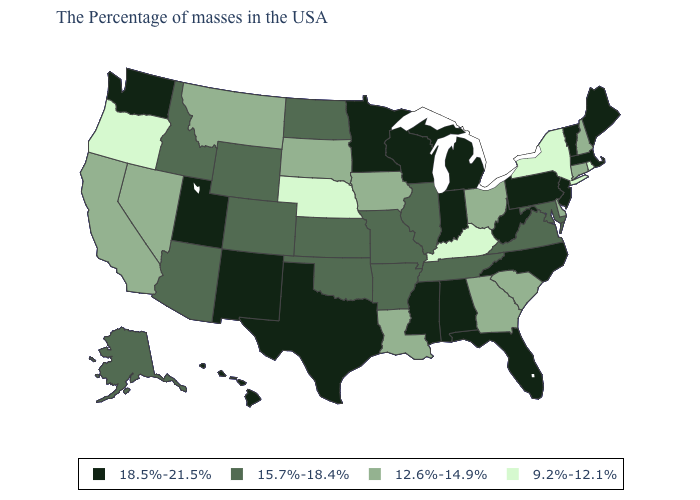Name the states that have a value in the range 18.5%-21.5%?
Answer briefly. Maine, Massachusetts, Vermont, New Jersey, Pennsylvania, North Carolina, West Virginia, Florida, Michigan, Indiana, Alabama, Wisconsin, Mississippi, Minnesota, Texas, New Mexico, Utah, Washington, Hawaii. Is the legend a continuous bar?
Give a very brief answer. No. What is the value of New Mexico?
Answer briefly. 18.5%-21.5%. Does South Dakota have the highest value in the USA?
Be succinct. No. Which states have the highest value in the USA?
Concise answer only. Maine, Massachusetts, Vermont, New Jersey, Pennsylvania, North Carolina, West Virginia, Florida, Michigan, Indiana, Alabama, Wisconsin, Mississippi, Minnesota, Texas, New Mexico, Utah, Washington, Hawaii. Does the first symbol in the legend represent the smallest category?
Answer briefly. No. How many symbols are there in the legend?
Write a very short answer. 4. What is the value of Maine?
Concise answer only. 18.5%-21.5%. Name the states that have a value in the range 12.6%-14.9%?
Concise answer only. New Hampshire, Connecticut, Delaware, South Carolina, Ohio, Georgia, Louisiana, Iowa, South Dakota, Montana, Nevada, California. Does Kentucky have the lowest value in the USA?
Keep it brief. Yes. Which states hav the highest value in the South?
Answer briefly. North Carolina, West Virginia, Florida, Alabama, Mississippi, Texas. What is the value of Arizona?
Short answer required. 15.7%-18.4%. Does North Carolina have the highest value in the South?
Quick response, please. Yes. Among the states that border Kentucky , which have the highest value?
Give a very brief answer. West Virginia, Indiana. Which states have the lowest value in the MidWest?
Quick response, please. Nebraska. 